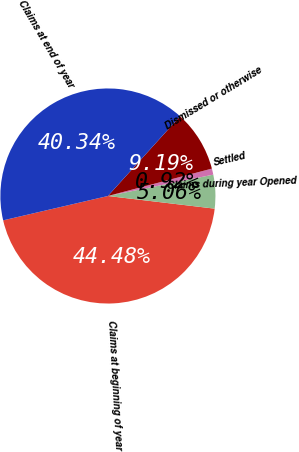<chart> <loc_0><loc_0><loc_500><loc_500><pie_chart><fcel>Claims at beginning of year<fcel>Claims during year Opened<fcel>Settled<fcel>Dismissed or otherwise<fcel>Claims at end of year<nl><fcel>44.48%<fcel>5.06%<fcel>0.92%<fcel>9.19%<fcel>40.34%<nl></chart> 